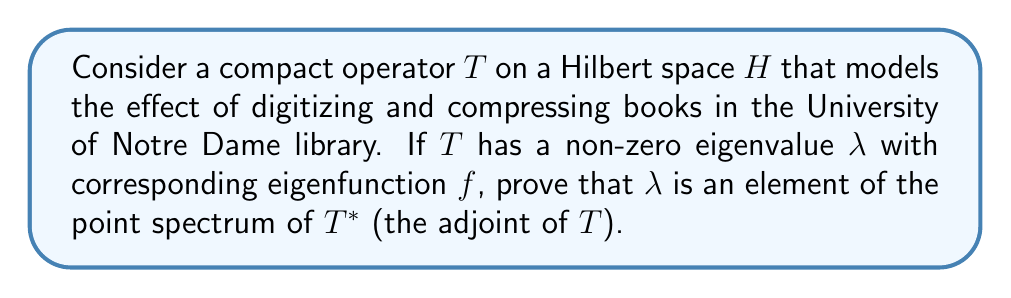Help me with this question. Let's approach this step-by-step:

1) First, recall that for a compact operator $T$ on a Hilbert space $H$, if $\lambda \neq 0$ is an eigenvalue of $T$ with corresponding eigenfunction $f$, then:

   $$Tf = \lambda f$$

2) Now, let's consider the adjoint operator $T^*$. We need to show that $\lambda$ is an eigenvalue of $T^*$.

3) For any $g \in H$, we have:

   $$\langle T^*g, f \rangle = \langle g, Tf \rangle = \langle g, \lambda f \rangle = \overline{\lambda} \langle g, f \rangle$$

   Here, we've used the definition of the adjoint and the fact that $Tf = \lambda f$.

4) On the other hand:

   $$\langle T^*g, f \rangle = \langle g, T^*f \rangle$$

5) Combining steps 3 and 4:

   $$\langle g, T^*f \rangle = \overline{\lambda} \langle g, f \rangle$$

6) Since this holds for all $g \in H$, we can conclude:

   $$T^*f = \overline{\lambda}f$$

7) This shows that $\overline{\lambda}$ is an eigenvalue of $T^*$ with eigenfunction $f$.

8) For compact operators on complex Hilbert spaces, the spectrum is symmetric with respect to the real axis. This means that if $\lambda$ is in the spectrum of $T$, then $\overline{\lambda}$ is in the spectrum of $T^*$.

9) Therefore, $\lambda$ is an eigenvalue of $T^*$, and thus an element of the point spectrum of $T^*$.
Answer: $\lambda$ is indeed an element of the point spectrum of $T^*$. Specifically, $\overline{\lambda}$ is an eigenvalue of $T^*$ with the same eigenfunction $f$ as $T$. 